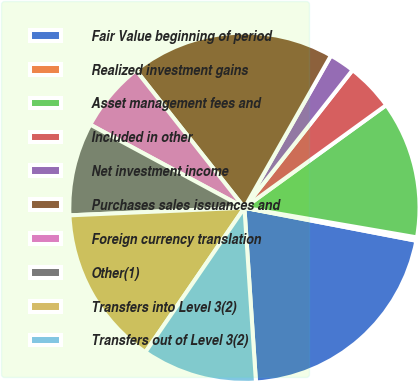<chart> <loc_0><loc_0><loc_500><loc_500><pie_chart><fcel>Fair Value beginning of period<fcel>Realized investment gains<fcel>Asset management fees and<fcel>Included in other<fcel>Net investment income<fcel>Purchases sales issuances and<fcel>Foreign currency translation<fcel>Other(1)<fcel>Transfers into Level 3(2)<fcel>Transfers out of Level 3(2)<nl><fcel>20.93%<fcel>0.31%<fcel>12.68%<fcel>4.43%<fcel>2.37%<fcel>18.86%<fcel>6.5%<fcel>8.56%<fcel>14.74%<fcel>10.62%<nl></chart> 